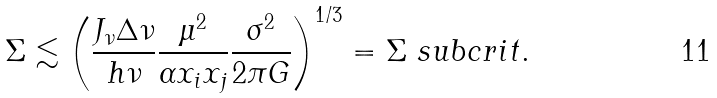<formula> <loc_0><loc_0><loc_500><loc_500>\Sigma \lesssim \left ( \frac { J _ { \nu } \Delta \nu } { h \nu } \frac { \mu ^ { 2 } } { \alpha x _ { i } x _ { j } } \frac { \sigma ^ { 2 } } { 2 \pi G } \right ) ^ { 1 / 3 } = \Sigma \ s u b c r i t .</formula> 